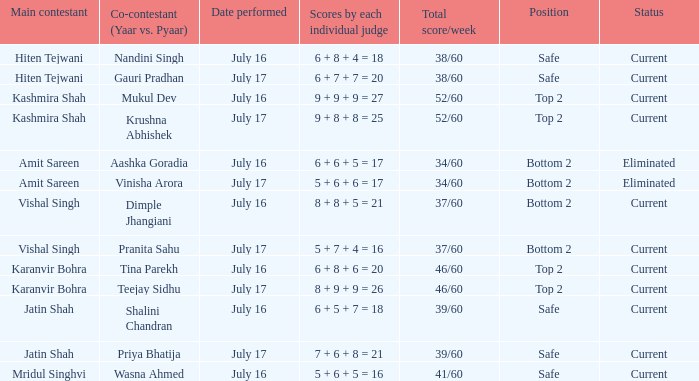What position did Pranita Sahu's team get? Bottom 2. 